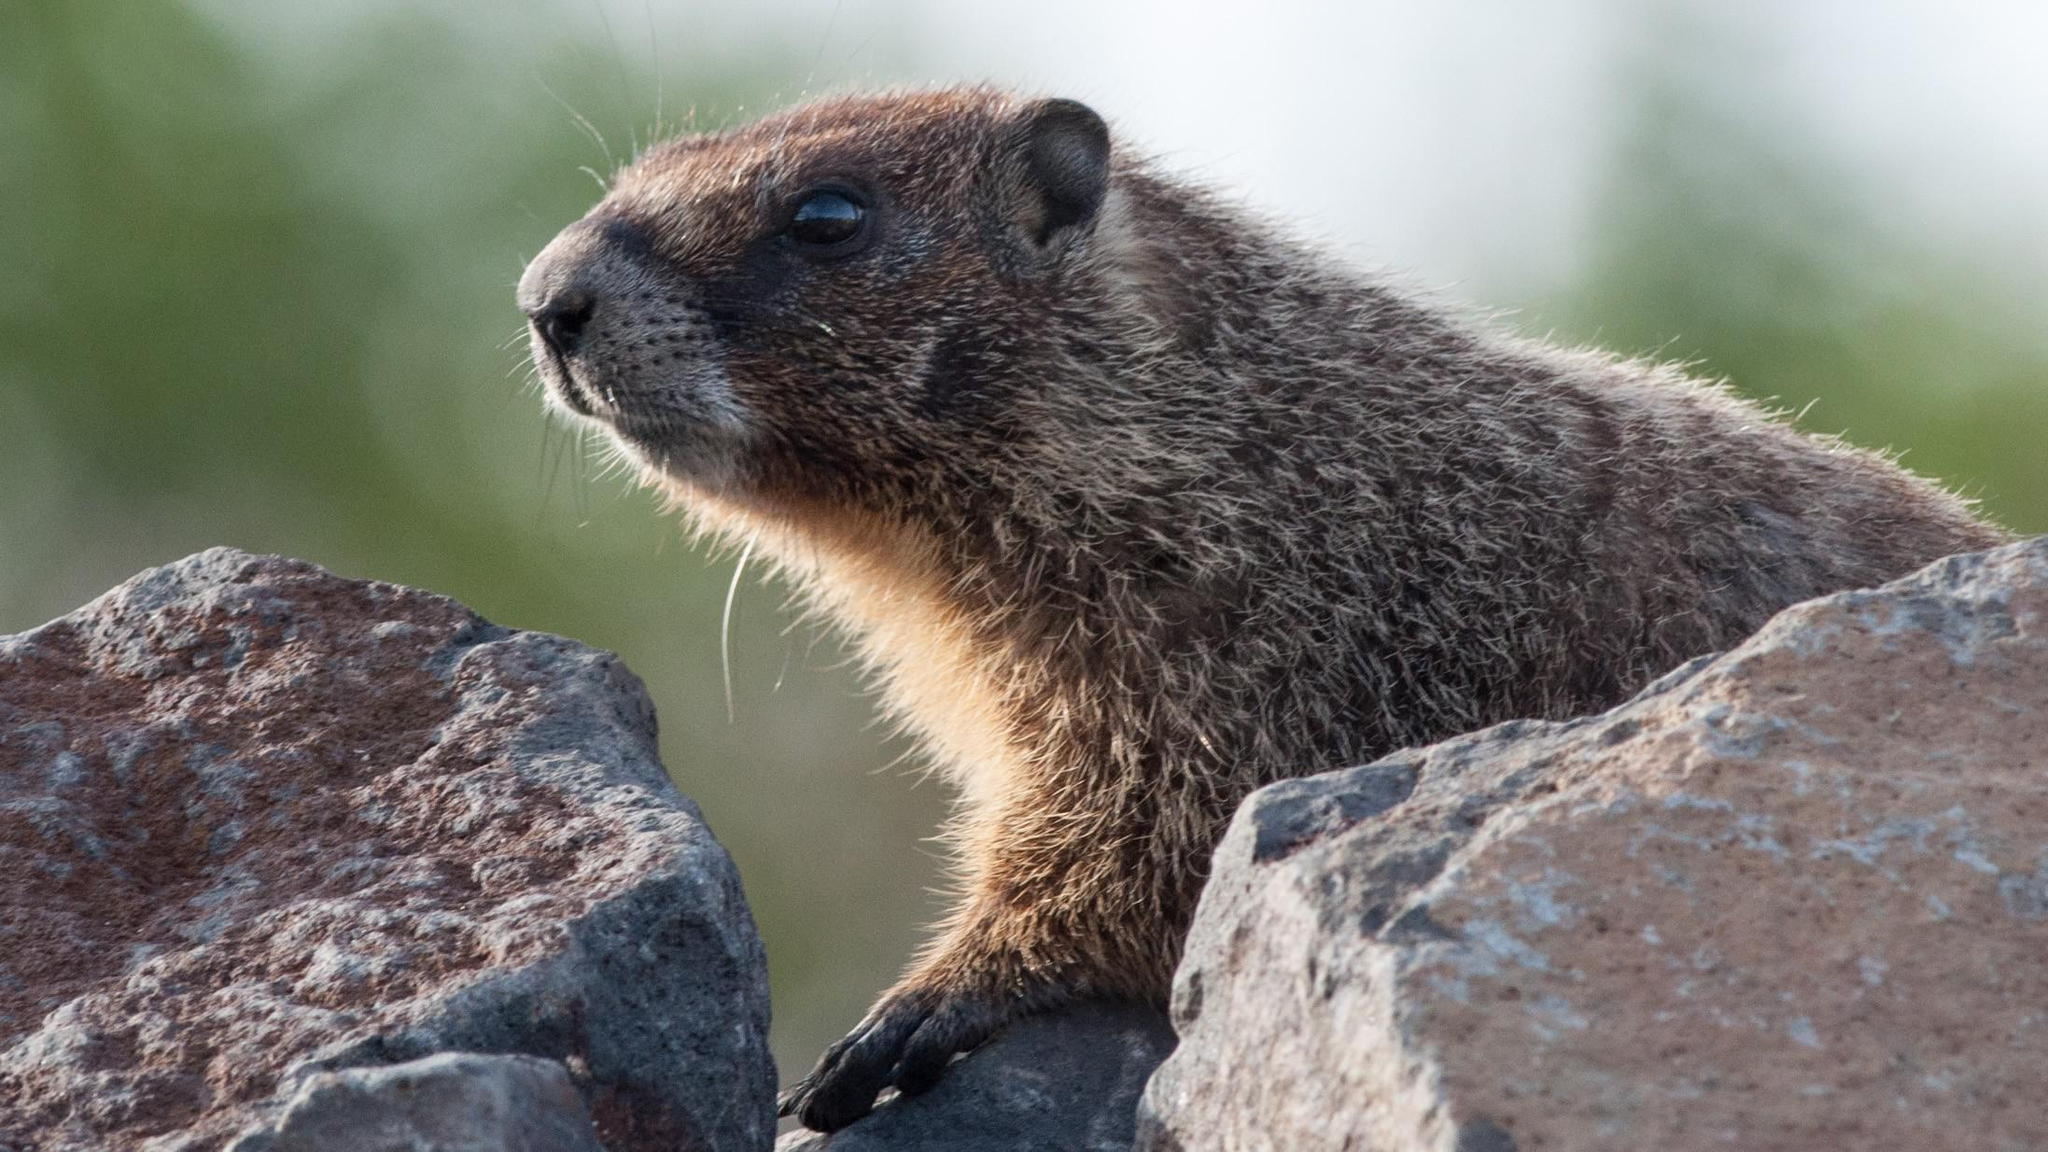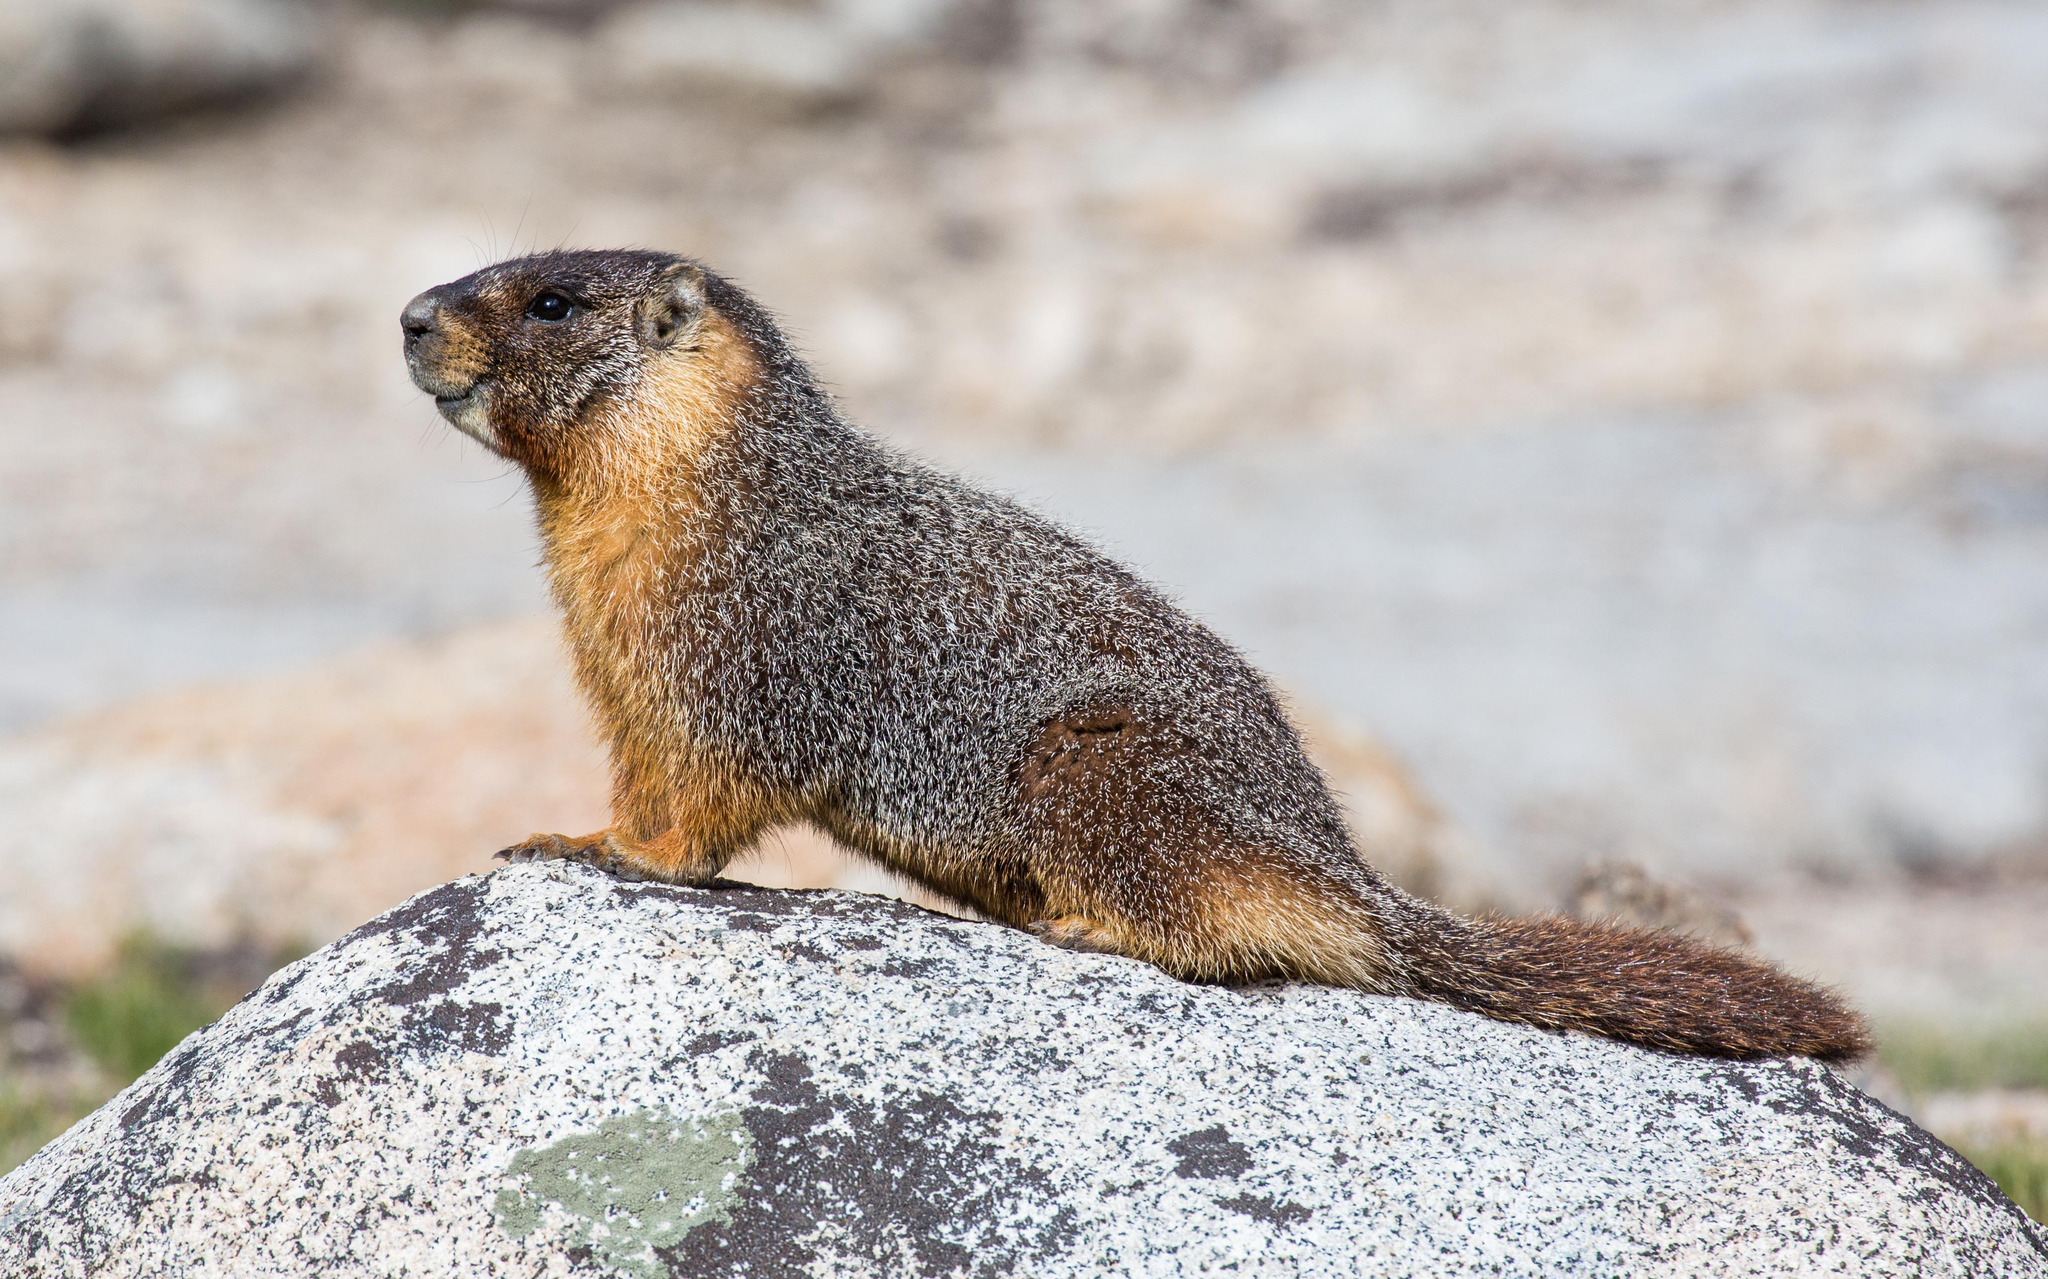The first image is the image on the left, the second image is the image on the right. For the images shown, is this caption "At least one of the small mammals is looking directly to the right, alone in it's own image." true? Answer yes or no. No. The first image is the image on the left, the second image is the image on the right. Examine the images to the left and right. Is the description "The left and right image contains a total of two groundhogs facing the same direction." accurate? Answer yes or no. Yes. 